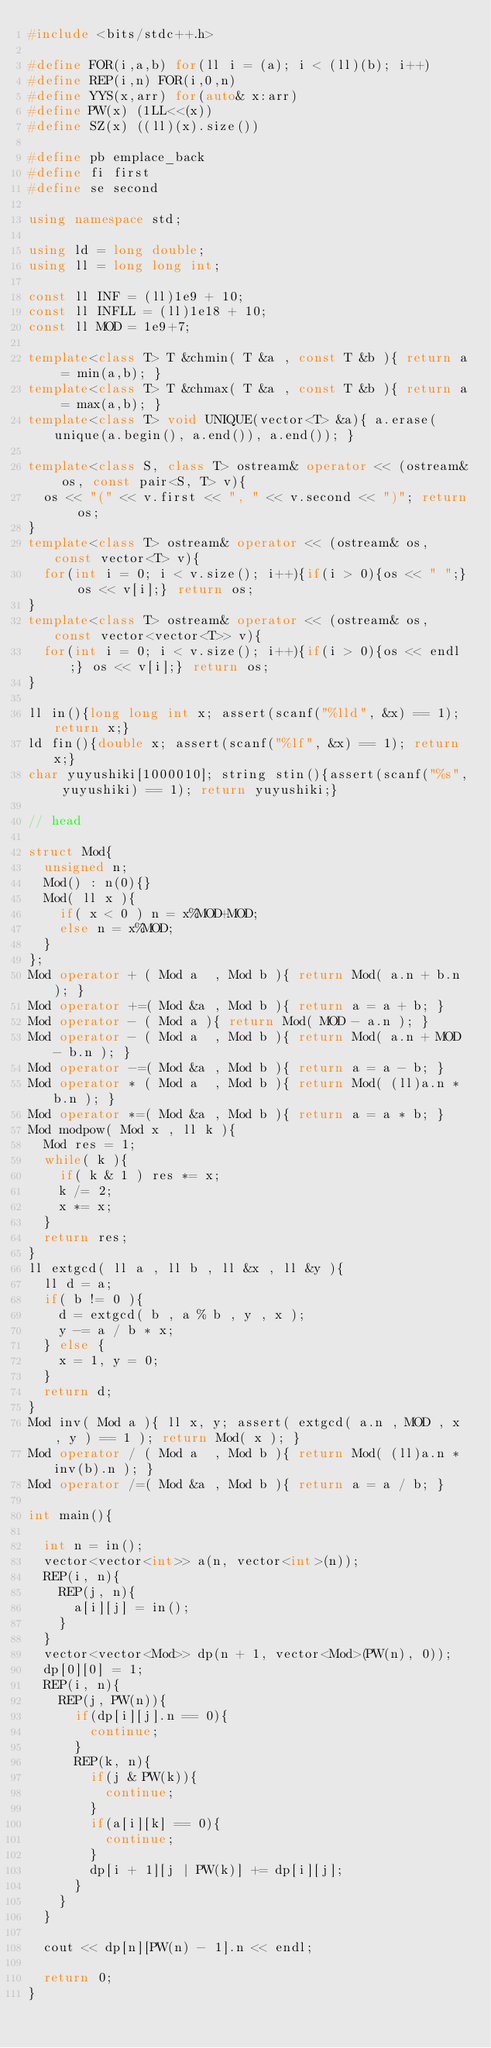Convert code to text. <code><loc_0><loc_0><loc_500><loc_500><_C++_>#include <bits/stdc++.h>
      
#define FOR(i,a,b) for(ll i = (a); i < (ll)(b); i++)
#define REP(i,n) FOR(i,0,n)
#define YYS(x,arr) for(auto& x:arr)
#define PW(x) (1LL<<(x))
#define SZ(x) ((ll)(x).size())

#define pb emplace_back
#define fi first
#define se second

using namespace std;

using ld = long double;
using ll = long long int;

const ll INF = (ll)1e9 + 10;
const ll INFLL = (ll)1e18 + 10;
const ll MOD = 1e9+7;
     
template<class T> T &chmin( T &a , const T &b ){ return a = min(a,b); }
template<class T> T &chmax( T &a , const T &b ){ return a = max(a,b); }
template<class T> void UNIQUE(vector<T> &a){ a.erase(unique(a.begin(), a.end()), a.end()); }

template<class S, class T> ostream& operator << (ostream& os, const pair<S, T> v){
  os << "(" << v.first << ", " << v.second << ")"; return os;
}
template<class T> ostream& operator << (ostream& os, const vector<T> v){
  for(int i = 0; i < v.size(); i++){if(i > 0){os << " ";} os << v[i];} return os;
}
template<class T> ostream& operator << (ostream& os, const vector<vector<T>> v){
  for(int i = 0; i < v.size(); i++){if(i > 0){os << endl;} os << v[i];} return os;
}

ll in(){long long int x; assert(scanf("%lld", &x) == 1); return x;}
ld fin(){double x; assert(scanf("%lf", &x) == 1); return x;}
char yuyushiki[1000010]; string stin(){assert(scanf("%s", yuyushiki) == 1); return yuyushiki;}

// head

struct Mod{
  unsigned n;
  Mod() : n(0){}
  Mod( ll x ){
    if( x < 0 ) n = x%MOD+MOD;
    else n = x%MOD;
  }
};
Mod operator + ( Mod a  , Mod b ){ return Mod( a.n + b.n ); }
Mod operator +=( Mod &a , Mod b ){ return a = a + b; }
Mod operator - ( Mod a ){ return Mod( MOD - a.n ); }
Mod operator - ( Mod a  , Mod b ){ return Mod( a.n + MOD - b.n ); }
Mod operator -=( Mod &a , Mod b ){ return a = a - b; }
Mod operator * ( Mod a  , Mod b ){ return Mod( (ll)a.n * b.n ); }
Mod operator *=( Mod &a , Mod b ){ return a = a * b; }
Mod modpow( Mod x , ll k ){
  Mod res = 1;
  while( k ){
    if( k & 1 ) res *= x;
    k /= 2;
    x *= x;
  }
  return res;
}
ll extgcd( ll a , ll b , ll &x , ll &y ){
  ll d = a;
  if( b != 0 ){
    d = extgcd( b , a % b , y , x );
    y -= a / b * x;
  } else {
    x = 1, y = 0;
  }
  return d;
}
Mod inv( Mod a ){ ll x, y; assert( extgcd( a.n , MOD , x , y ) == 1 ); return Mod( x ); }
Mod operator / ( Mod a  , Mod b ){ return Mod( (ll)a.n * inv(b).n ); }
Mod operator /=( Mod &a , Mod b ){ return a = a / b; }

int main(){

  int n = in();
  vector<vector<int>> a(n, vector<int>(n));
  REP(i, n){
    REP(j, n){
      a[i][j] = in();
    }
  }
  vector<vector<Mod>> dp(n + 1, vector<Mod>(PW(n), 0));
  dp[0][0] = 1;
  REP(i, n){
    REP(j, PW(n)){
      if(dp[i][j].n == 0){
        continue;
      }
      REP(k, n){
        if(j & PW(k)){
          continue;
        }
        if(a[i][k] == 0){
          continue;
        }
        dp[i + 1][j | PW(k)] += dp[i][j];
      }
    }
  }

  cout << dp[n][PW(n) - 1].n << endl;
  
  return 0;
}
</code> 